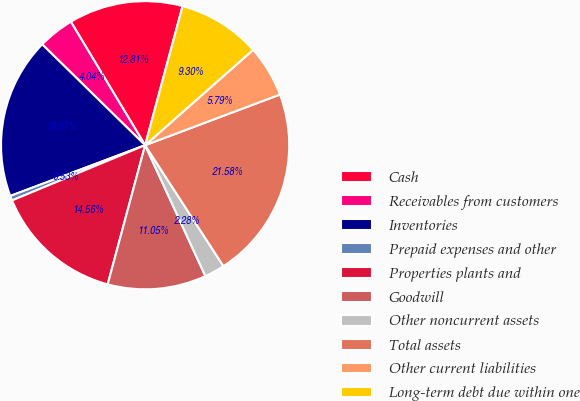<chart> <loc_0><loc_0><loc_500><loc_500><pie_chart><fcel>Cash<fcel>Receivables from customers<fcel>Inventories<fcel>Prepaid expenses and other<fcel>Properties plants and<fcel>Goodwill<fcel>Other noncurrent assets<fcel>Total assets<fcel>Other current liabilities<fcel>Long-term debt due within one<nl><fcel>12.81%<fcel>4.04%<fcel>18.07%<fcel>0.53%<fcel>14.56%<fcel>11.05%<fcel>2.28%<fcel>21.58%<fcel>5.79%<fcel>9.3%<nl></chart> 